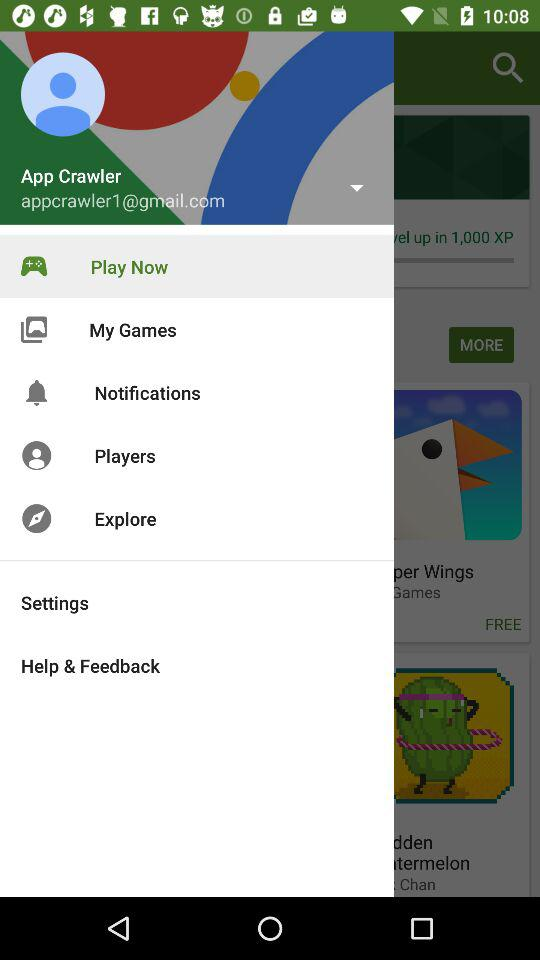Which item is currently selected in the menu? The currently selected item in the menu is "Play Now". 